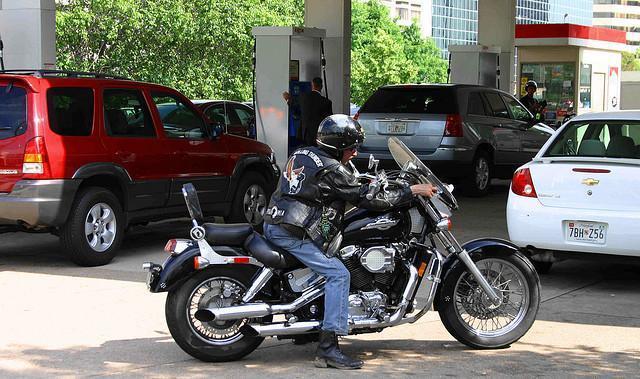How many buses can be seen in this picture?
Give a very brief answer. 0. How many cars are there?
Give a very brief answer. 3. How many oranges are there?
Give a very brief answer. 0. 